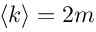Convert formula to latex. <formula><loc_0><loc_0><loc_500><loc_500>\left < k \right > = 2 m</formula> 